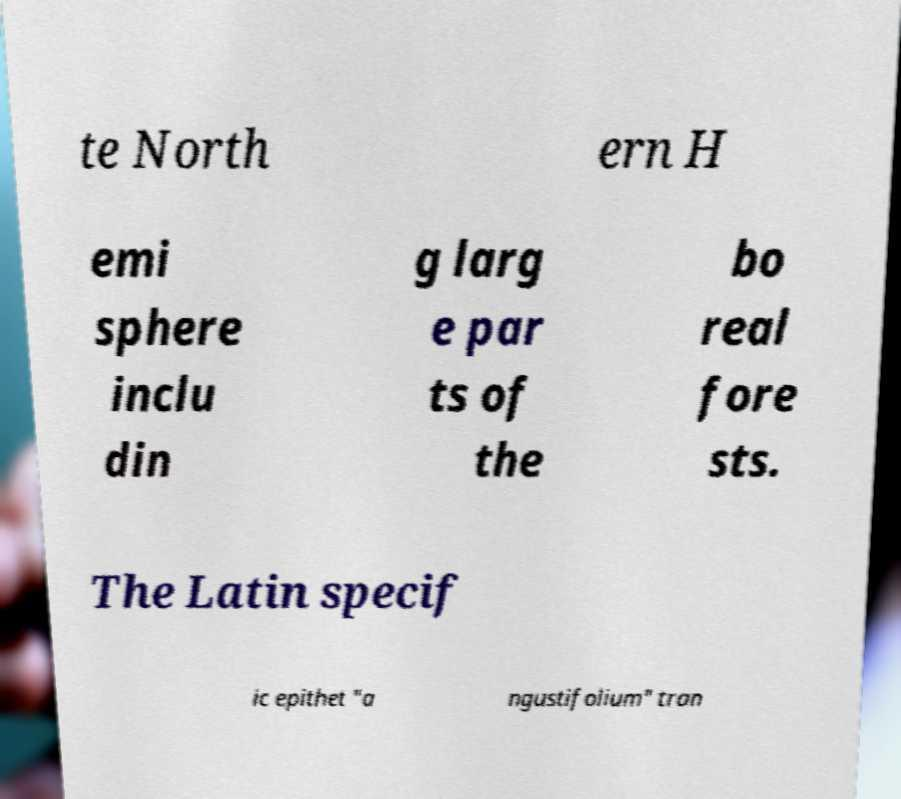Could you extract and type out the text from this image? te North ern H emi sphere inclu din g larg e par ts of the bo real fore sts. The Latin specif ic epithet "a ngustifolium" tran 